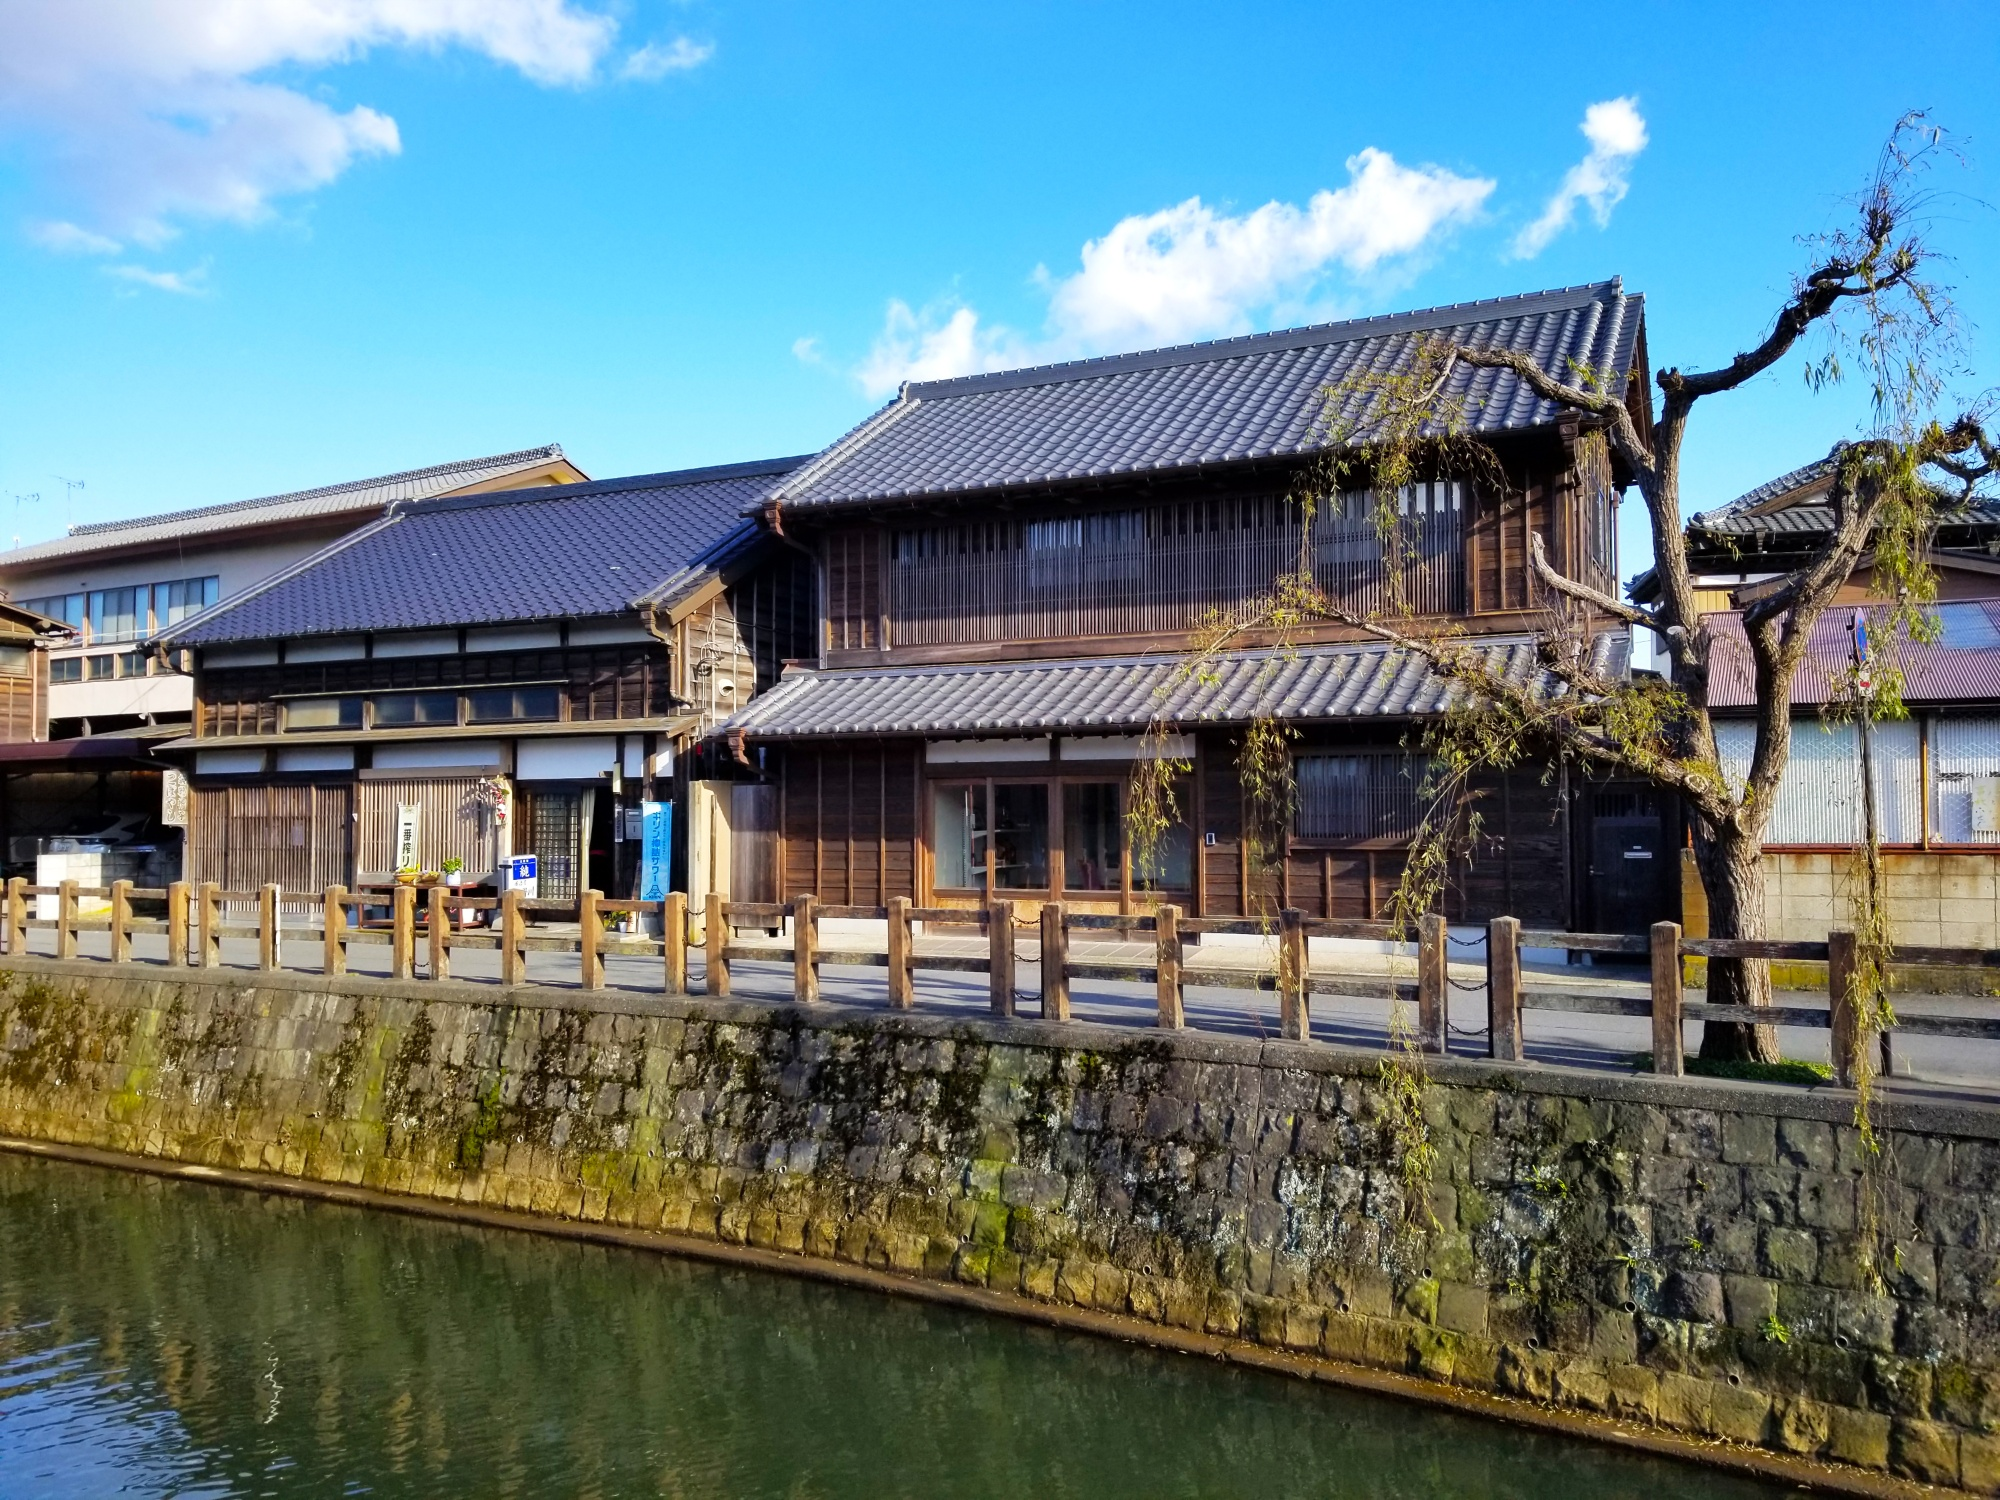Write a detailed description of the given image. The image showcases a picturesque view of a traditional Japanese streetscape situated alongside a calm river. The depicted architecture is quintessentially Japanese with wooden facades and curved tiled roofs, indicating the historical and cultural significance of the area. A quaint stone wall runs along the riverbank, ensuring a delineated separation between the calm flowing water and the pathway next to the buildings. This setting is further accentuated by the presence of a dormant, leafless tree beside the pathway, highlighting the winter season. The sky, partly cloudy yet bright, casts a natural light that vividly enhances the colors and textures of the scene, reflecting the tranquility typical of a quiet neighborhood in Japan. The overall composition of the photograph, with its emphasis on symmetry and natural beauty, invites the viewer to appreciate the peaceful coexistence of traditional architecture and nature. 